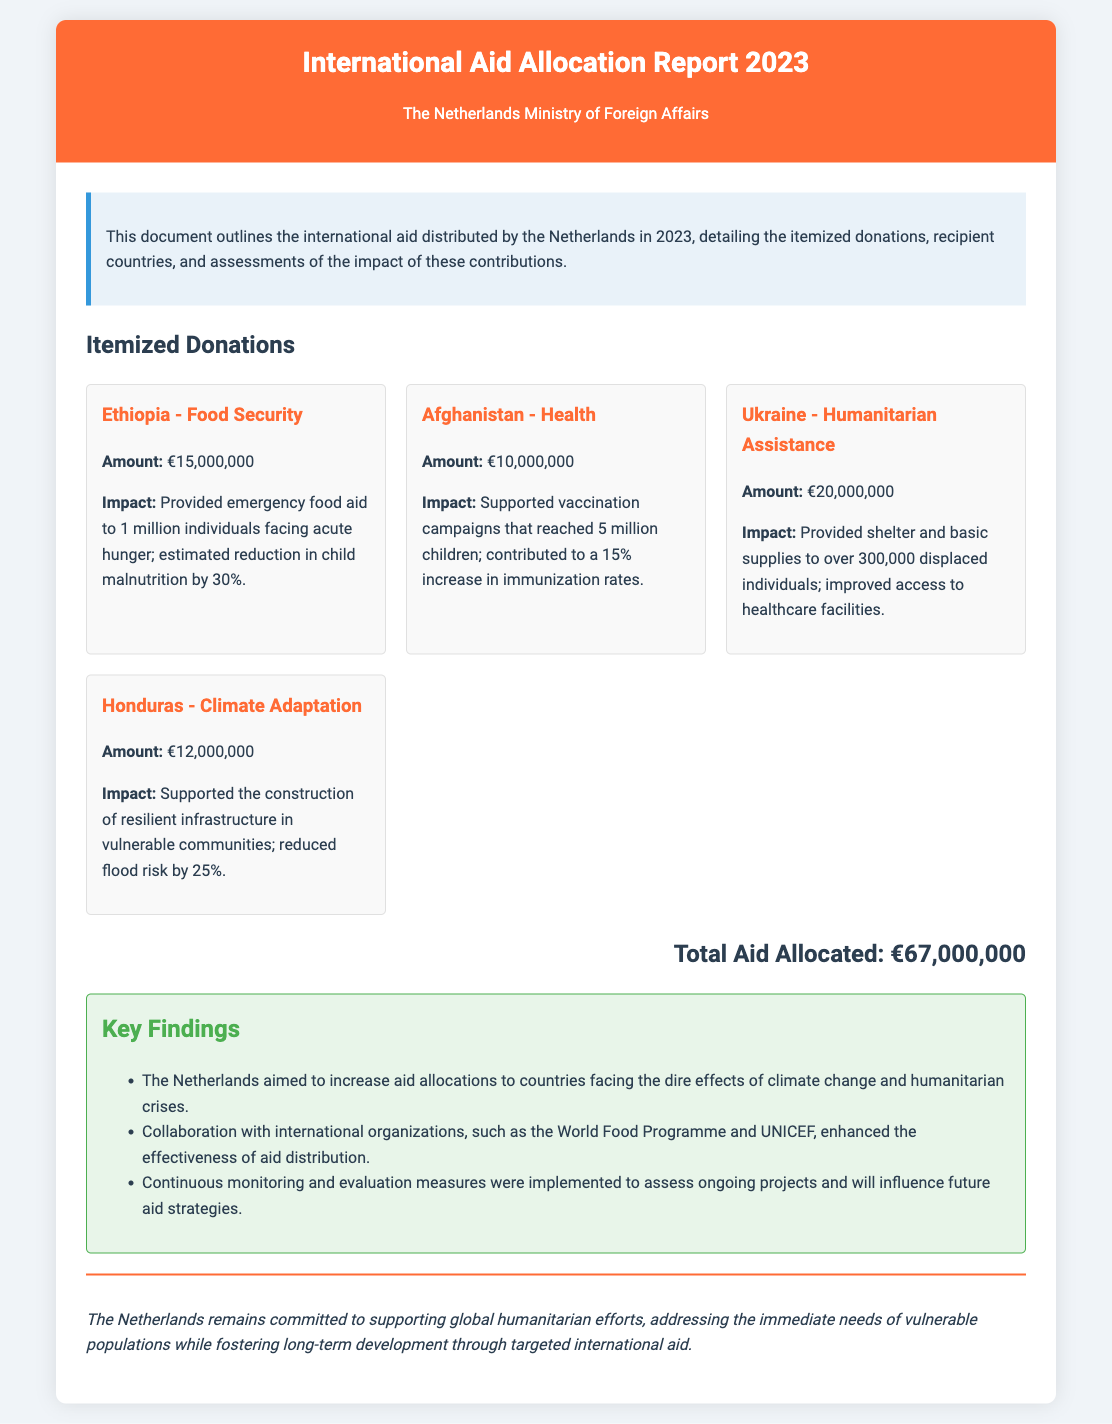What is the total aid allocated? The total aid allocated is explicitly stated in the document's total section, summing all itemized donations.
Answer: €67,000,000 What is the amount donated to Ethiopia? The donation amount to Ethiopia can be found in the "Itemized Donations" section under Ethiopia - Food Security.
Answer: €15,000,000 How many individuals received shelter and basic supplies in Ukraine? The document mentions the number of displaced individuals who received aid in the Ukraine section.
Answer: 300,000 What was the percentage reduction in child malnutrition in Ethiopia? The impact assessment for Ethiopia mentions the specific reduction percentage for child malnutrition.
Answer: 30% Which country received funding for climate adaptation? The itemized donations section lists the country associated with climate adaptation efforts.
Answer: Honduras What was the focus of the donation to Afghanistan? The document specifies the focus area for the funds allocated to Afghanistan in the respective section.
Answer: Health What international organization was mentioned in the key findings? The key findings list significant international organizations that collaborated with the Netherlands for aid distribution.
Answer: World Food Programme What construction was supported in Honduras? The impact of the aid to Honduras details the type of infrastructure supported through funding.
Answer: Resilient infrastructure How many children were reached by vaccination campaigns in Afghanistan? The document provides the number of children who benefited from the vaccination campaigns in the corresponding donation section.
Answer: 5 million 